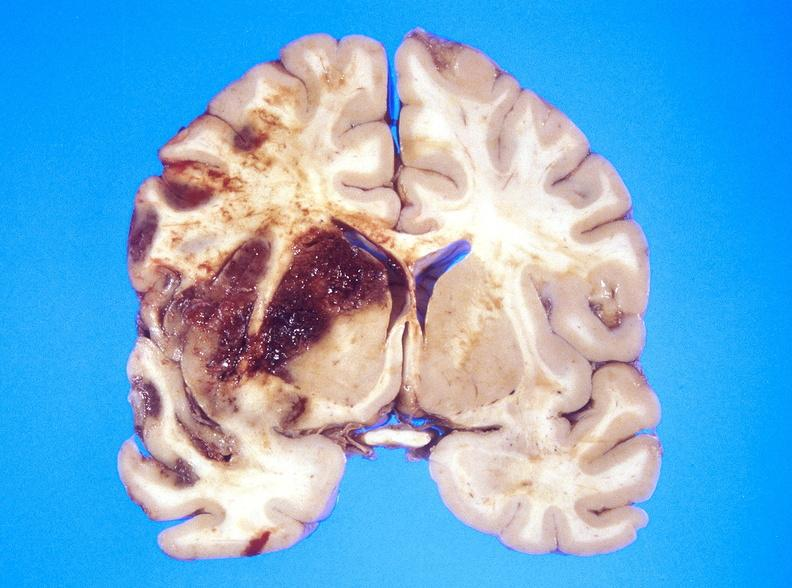what is present?
Answer the question using a single word or phrase. Nervous 